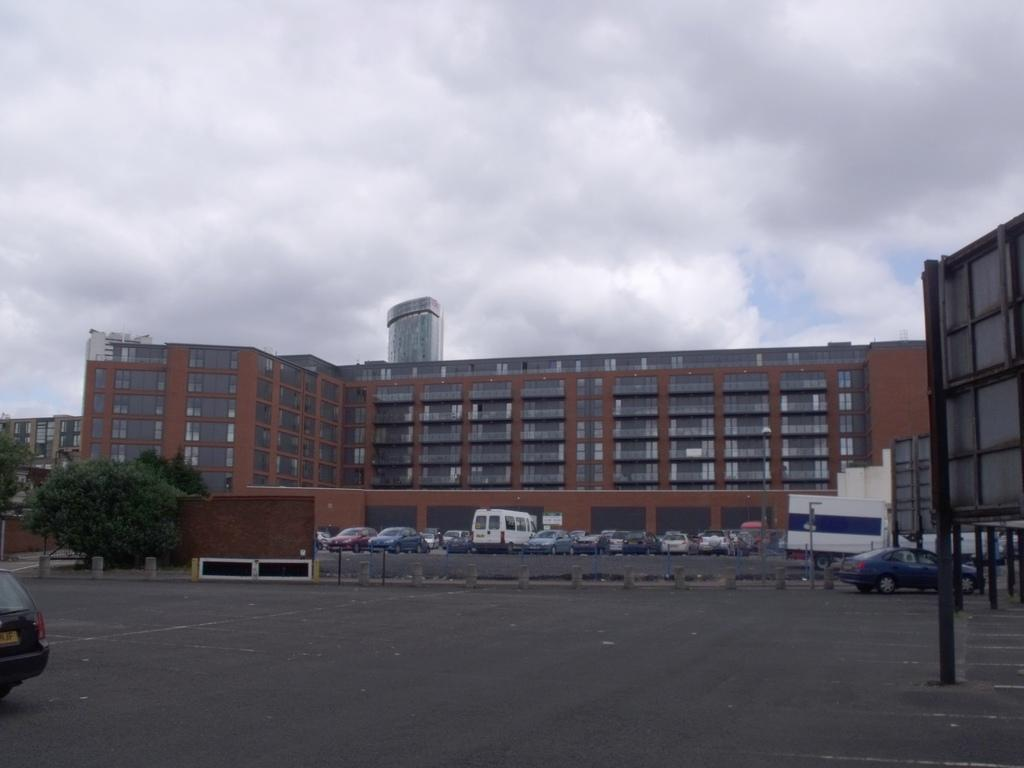What is located in the foreground of the picture? There is a hoarding and a car on the road in the foreground of the picture. What can be seen in the center of the picture? There are trees, cars and vehicles, fencing, and a building in the center of the picture. What is the condition of the sky in the picture? The sky is cloudy in the picture. Can you tell me how many times the car rolls over the stretch of road in the image? There is no indication of the car rolling over in the image; it is stationary on the road. What type of chain can be seen connecting the trees in the center of the picture? There is no chain connecting the trees in the image; the trees are separate entities. 